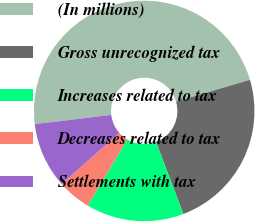Convert chart to OTSL. <chart><loc_0><loc_0><loc_500><loc_500><pie_chart><fcel>(In millions)<fcel>Gross unrecognized tax<fcel>Increases related to tax<fcel>Decreases related to tax<fcel>Settlements with tax<nl><fcel>47.36%<fcel>23.77%<fcel>14.34%<fcel>4.91%<fcel>9.62%<nl></chart> 